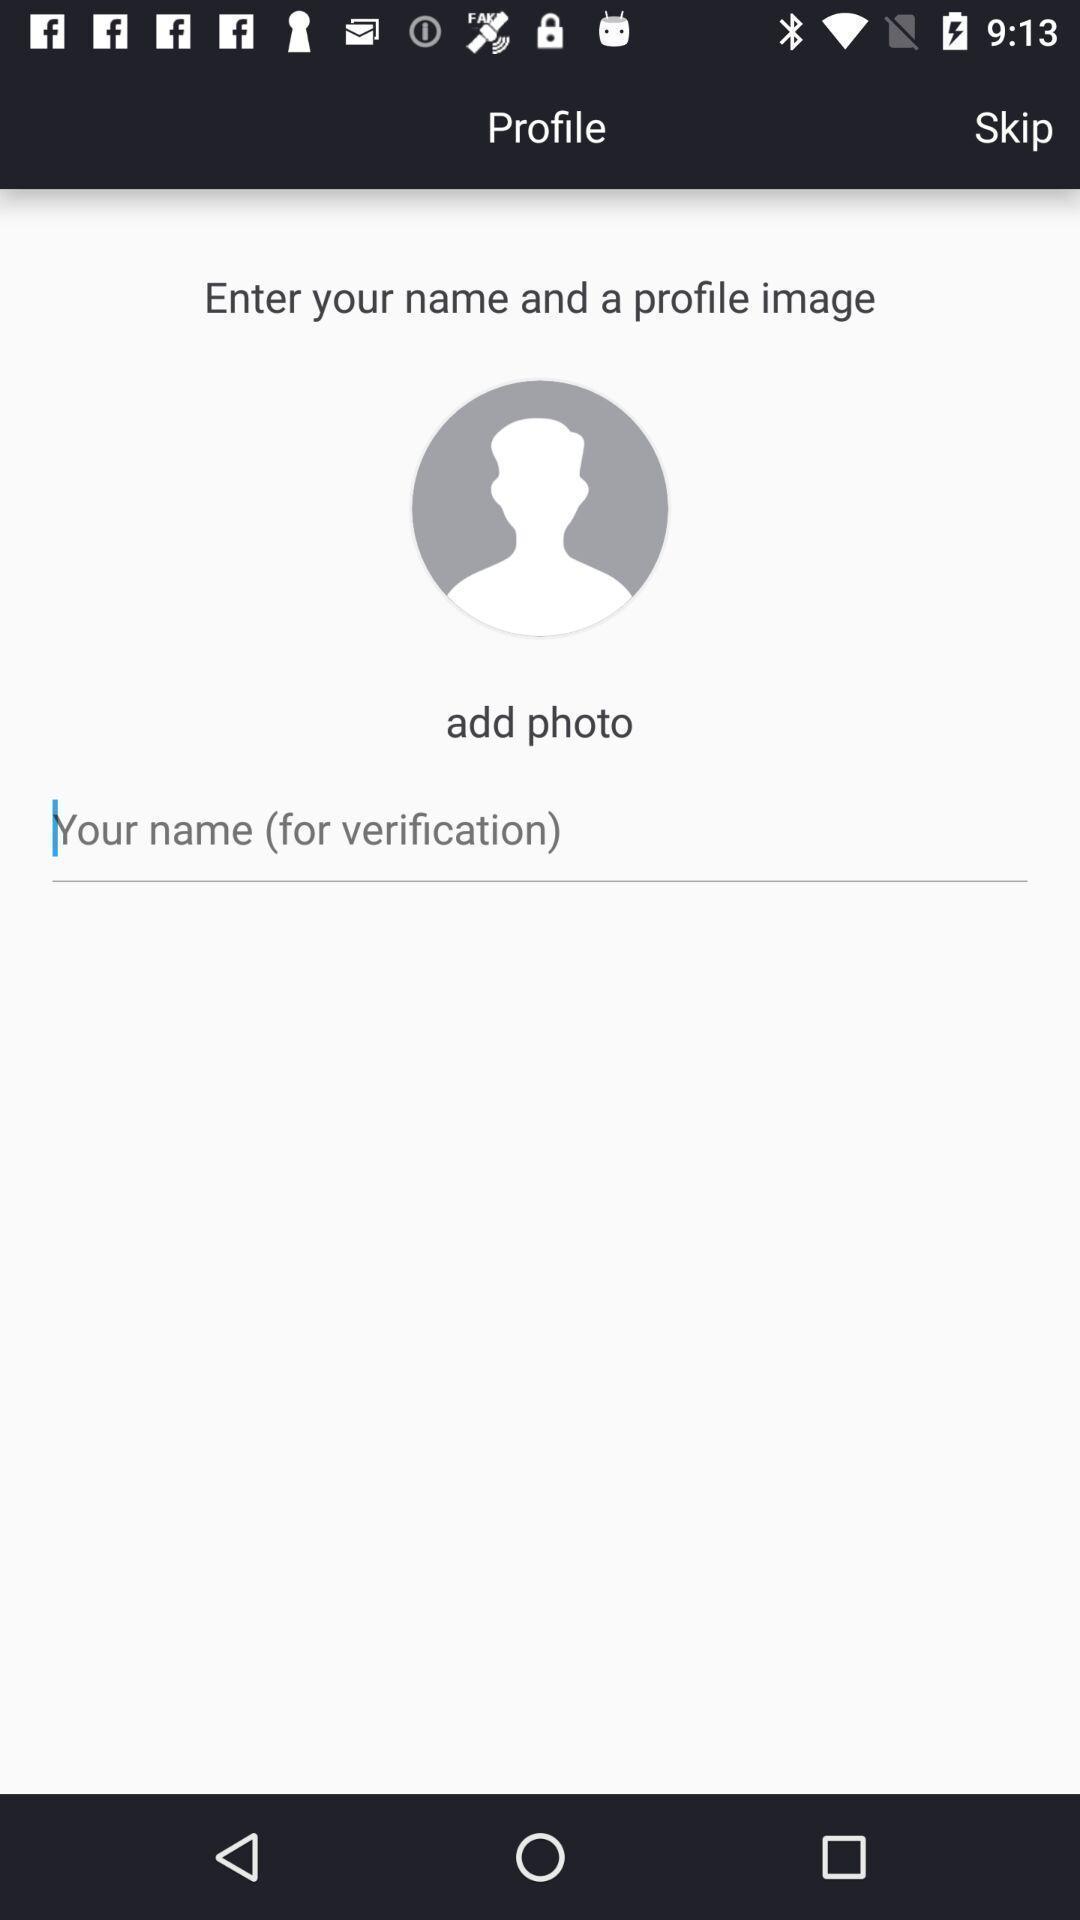Explain the elements present in this screenshot. Screen shows enter profile details. 